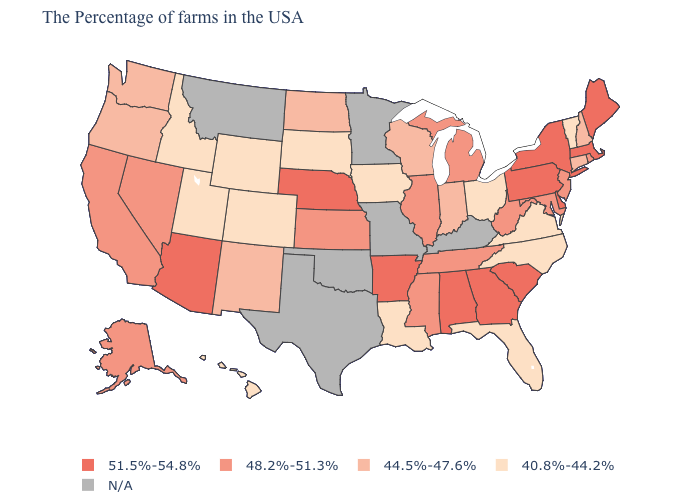Among the states that border Nevada , does Arizona have the highest value?
Keep it brief. Yes. Name the states that have a value in the range 44.5%-47.6%?
Quick response, please. New Hampshire, Connecticut, Indiana, Wisconsin, North Dakota, New Mexico, Washington, Oregon. Which states hav the highest value in the MidWest?
Answer briefly. Nebraska. Name the states that have a value in the range N/A?
Write a very short answer. Kentucky, Missouri, Minnesota, Oklahoma, Texas, Montana. Does Maryland have the lowest value in the South?
Quick response, please. No. How many symbols are there in the legend?
Answer briefly. 5. Name the states that have a value in the range 48.2%-51.3%?
Keep it brief. Rhode Island, New Jersey, Maryland, West Virginia, Michigan, Tennessee, Illinois, Mississippi, Kansas, Nevada, California, Alaska. What is the highest value in the South ?
Be succinct. 51.5%-54.8%. Name the states that have a value in the range 40.8%-44.2%?
Give a very brief answer. Vermont, Virginia, North Carolina, Ohio, Florida, Louisiana, Iowa, South Dakota, Wyoming, Colorado, Utah, Idaho, Hawaii. Name the states that have a value in the range 48.2%-51.3%?
Give a very brief answer. Rhode Island, New Jersey, Maryland, West Virginia, Michigan, Tennessee, Illinois, Mississippi, Kansas, Nevada, California, Alaska. What is the value of Hawaii?
Write a very short answer. 40.8%-44.2%. What is the value of New York?
Concise answer only. 51.5%-54.8%. Name the states that have a value in the range N/A?
Be succinct. Kentucky, Missouri, Minnesota, Oklahoma, Texas, Montana. 